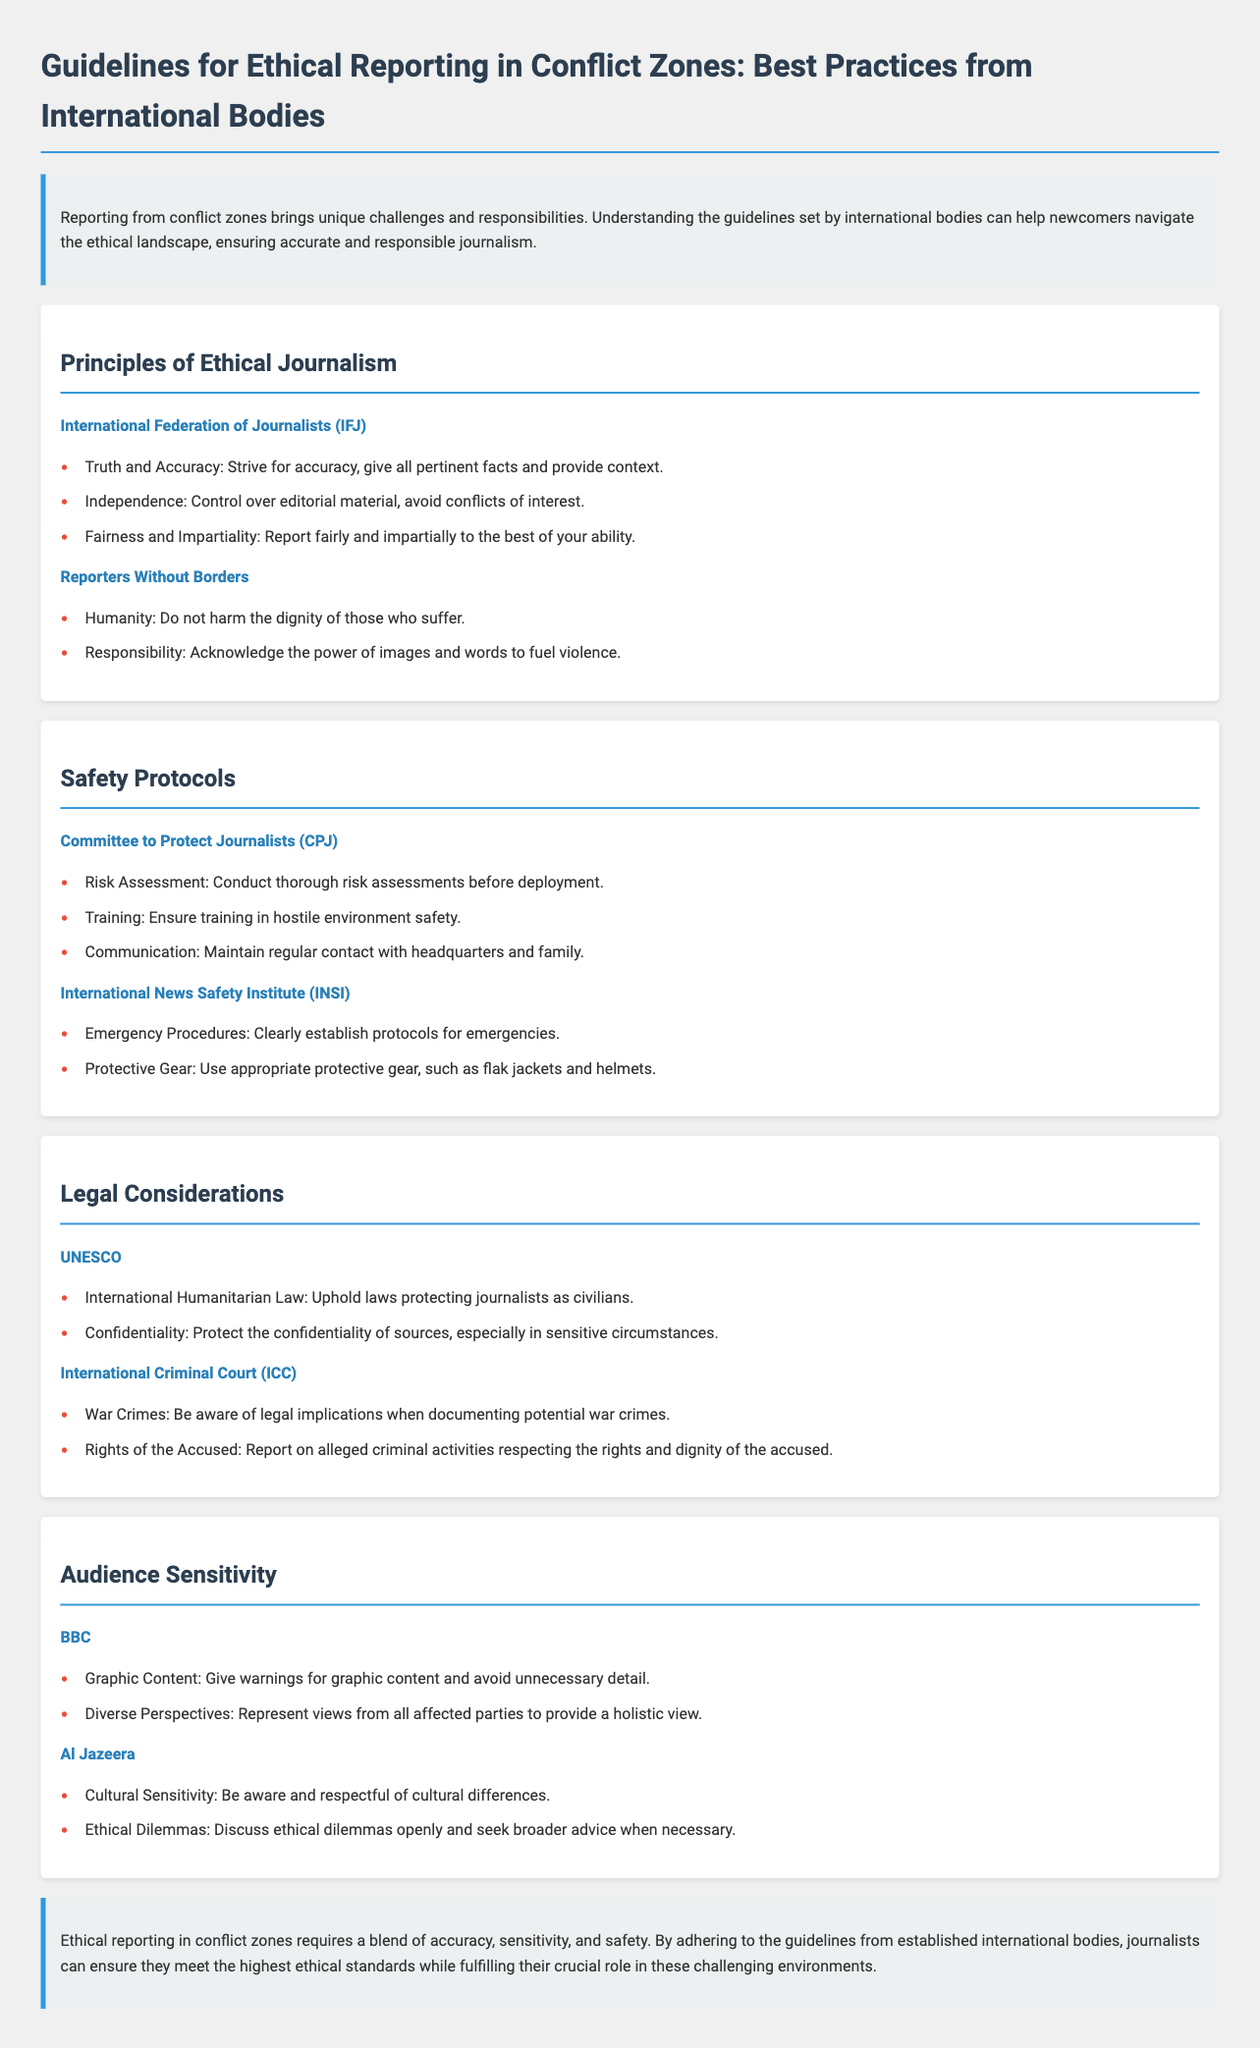What are the principles of ethical journalism? The principles of ethical journalism are outlined by two organizations and include key tenets such as truth, independence, and humanity, among others.
Answer: Truth and Accuracy, Independence, Fairness and Impartiality, Humanity, Responsibility Which organization emphasizes safety protocols for journalists? The document lists the Committee to Protect Journalists as one of the organizations focusing on safety protocols for journalists operating in conflict zones.
Answer: Committee to Protect Journalists What should journalists maintain during conflict reporting according to the CPJ? The CPJ highlights the need for journalists to ensure communication during conflict reporting; this includes staying in touch with headquarters and family.
Answer: Communication What legal consideration should journalists uphold according to UNESCO? UNESCO emphasizes the importance of upholding international humanitarian law in relation to journalists.
Answer: International Humanitarian Law What does the BBC advise regarding graphic content? The BBC advises journalists to issue warnings for graphic content to prepare the audience adequately.
Answer: Graphic Content What is a key aspect of audience sensitivity mentioned by Al Jazeera? Al Jazeera advises being culturally aware and respectful; this aspect is critical when representing diverse communities.
Answer: Cultural Sensitivity What type of content should journalists provide warnings for? The document specifies that warnings should be given for graphic content to manage audience expectations and sensitivities.
Answer: Graphic Content What emergency protocol is recommended by INSI? The International News Safety Institute recommends establishing clear emergency procedures for journalists in conflict zones.
Answer: Emergency Procedures Which two organizations contribute to the principles of ethical journalism? The document mentions the International Federation of Journalists and Reporters Without Borders as key contributors to ethical journalism principles.
Answer: International Federation of Journalists, Reporters Without Borders 